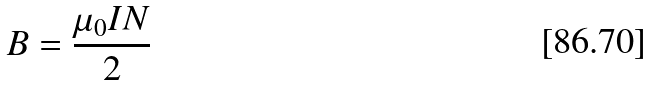<formula> <loc_0><loc_0><loc_500><loc_500>B = \frac { \mu _ { 0 } I N } { 2 }</formula> 